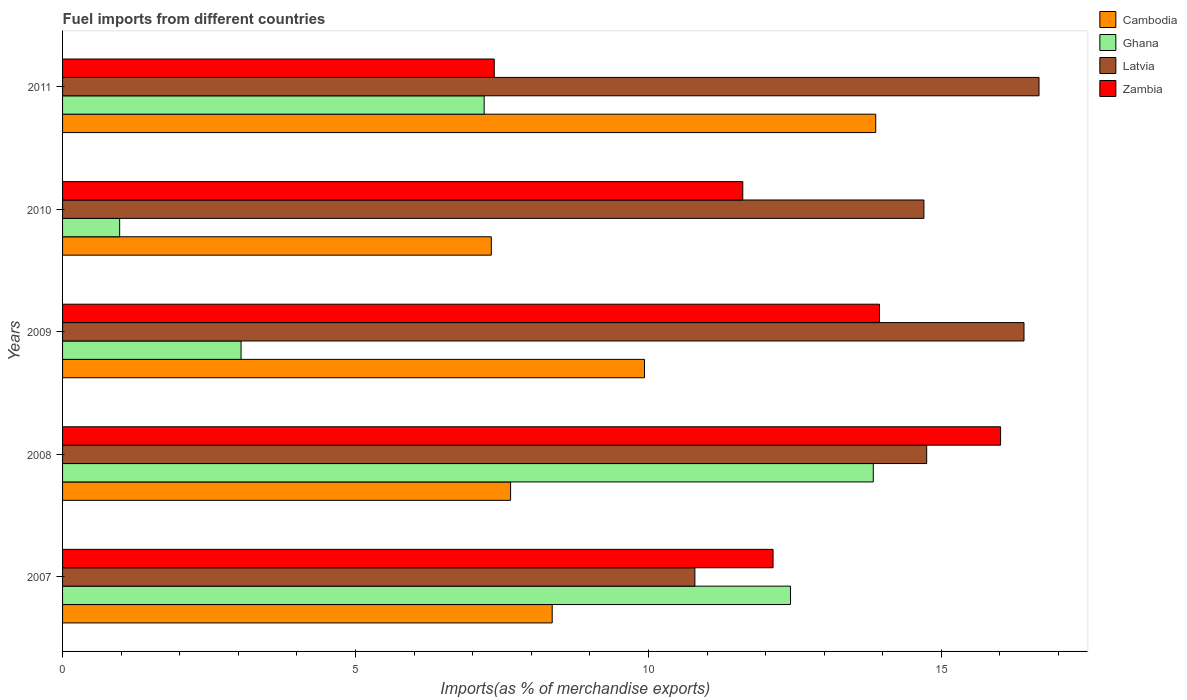How many groups of bars are there?
Keep it short and to the point. 5. Are the number of bars per tick equal to the number of legend labels?
Make the answer very short. Yes. Are the number of bars on each tick of the Y-axis equal?
Your answer should be very brief. Yes. How many bars are there on the 2nd tick from the top?
Provide a succinct answer. 4. What is the label of the 3rd group of bars from the top?
Provide a succinct answer. 2009. In how many cases, is the number of bars for a given year not equal to the number of legend labels?
Give a very brief answer. 0. What is the percentage of imports to different countries in Cambodia in 2007?
Your answer should be very brief. 8.36. Across all years, what is the maximum percentage of imports to different countries in Ghana?
Keep it short and to the point. 13.84. Across all years, what is the minimum percentage of imports to different countries in Cambodia?
Provide a short and direct response. 7.32. In which year was the percentage of imports to different countries in Zambia maximum?
Offer a terse response. 2008. In which year was the percentage of imports to different countries in Cambodia minimum?
Keep it short and to the point. 2010. What is the total percentage of imports to different countries in Zambia in the graph?
Ensure brevity in your answer.  61.06. What is the difference between the percentage of imports to different countries in Zambia in 2009 and that in 2010?
Offer a very short reply. 2.33. What is the difference between the percentage of imports to different countries in Zambia in 2009 and the percentage of imports to different countries in Ghana in 2007?
Ensure brevity in your answer.  1.52. What is the average percentage of imports to different countries in Zambia per year?
Your response must be concise. 12.21. In the year 2011, what is the difference between the percentage of imports to different countries in Ghana and percentage of imports to different countries in Cambodia?
Keep it short and to the point. -6.68. In how many years, is the percentage of imports to different countries in Ghana greater than 11 %?
Give a very brief answer. 2. What is the ratio of the percentage of imports to different countries in Latvia in 2008 to that in 2011?
Keep it short and to the point. 0.88. What is the difference between the highest and the second highest percentage of imports to different countries in Cambodia?
Offer a very short reply. 3.95. What is the difference between the highest and the lowest percentage of imports to different countries in Cambodia?
Provide a short and direct response. 6.56. Is the sum of the percentage of imports to different countries in Latvia in 2008 and 2009 greater than the maximum percentage of imports to different countries in Cambodia across all years?
Offer a terse response. Yes. Is it the case that in every year, the sum of the percentage of imports to different countries in Ghana and percentage of imports to different countries in Cambodia is greater than the sum of percentage of imports to different countries in Latvia and percentage of imports to different countries in Zambia?
Offer a terse response. No. What does the 1st bar from the top in 2011 represents?
Offer a very short reply. Zambia. What does the 4th bar from the bottom in 2010 represents?
Provide a succinct answer. Zambia. Are all the bars in the graph horizontal?
Make the answer very short. Yes. What is the difference between two consecutive major ticks on the X-axis?
Your answer should be very brief. 5. Does the graph contain any zero values?
Your answer should be compact. No. Does the graph contain grids?
Make the answer very short. No. How many legend labels are there?
Provide a succinct answer. 4. What is the title of the graph?
Ensure brevity in your answer.  Fuel imports from different countries. Does "Mexico" appear as one of the legend labels in the graph?
Provide a short and direct response. No. What is the label or title of the X-axis?
Provide a succinct answer. Imports(as % of merchandise exports). What is the label or title of the Y-axis?
Provide a succinct answer. Years. What is the Imports(as % of merchandise exports) of Cambodia in 2007?
Give a very brief answer. 8.36. What is the Imports(as % of merchandise exports) in Ghana in 2007?
Provide a short and direct response. 12.43. What is the Imports(as % of merchandise exports) of Latvia in 2007?
Offer a very short reply. 10.79. What is the Imports(as % of merchandise exports) in Zambia in 2007?
Make the answer very short. 12.13. What is the Imports(as % of merchandise exports) in Cambodia in 2008?
Ensure brevity in your answer.  7.65. What is the Imports(as % of merchandise exports) of Ghana in 2008?
Offer a terse response. 13.84. What is the Imports(as % of merchandise exports) in Latvia in 2008?
Your response must be concise. 14.75. What is the Imports(as % of merchandise exports) of Zambia in 2008?
Make the answer very short. 16.01. What is the Imports(as % of merchandise exports) in Cambodia in 2009?
Provide a short and direct response. 9.93. What is the Imports(as % of merchandise exports) of Ghana in 2009?
Keep it short and to the point. 3.05. What is the Imports(as % of merchandise exports) in Latvia in 2009?
Ensure brevity in your answer.  16.41. What is the Imports(as % of merchandise exports) in Zambia in 2009?
Your answer should be compact. 13.94. What is the Imports(as % of merchandise exports) in Cambodia in 2010?
Ensure brevity in your answer.  7.32. What is the Imports(as % of merchandise exports) in Ghana in 2010?
Ensure brevity in your answer.  0.97. What is the Imports(as % of merchandise exports) of Latvia in 2010?
Offer a very short reply. 14.7. What is the Imports(as % of merchandise exports) of Zambia in 2010?
Your response must be concise. 11.61. What is the Imports(as % of merchandise exports) in Cambodia in 2011?
Make the answer very short. 13.88. What is the Imports(as % of merchandise exports) of Ghana in 2011?
Provide a short and direct response. 7.2. What is the Imports(as % of merchandise exports) in Latvia in 2011?
Make the answer very short. 16.67. What is the Imports(as % of merchandise exports) in Zambia in 2011?
Keep it short and to the point. 7.37. Across all years, what is the maximum Imports(as % of merchandise exports) in Cambodia?
Your response must be concise. 13.88. Across all years, what is the maximum Imports(as % of merchandise exports) of Ghana?
Your response must be concise. 13.84. Across all years, what is the maximum Imports(as % of merchandise exports) of Latvia?
Your answer should be very brief. 16.67. Across all years, what is the maximum Imports(as % of merchandise exports) of Zambia?
Offer a terse response. 16.01. Across all years, what is the minimum Imports(as % of merchandise exports) of Cambodia?
Your response must be concise. 7.32. Across all years, what is the minimum Imports(as % of merchandise exports) in Ghana?
Your answer should be very brief. 0.97. Across all years, what is the minimum Imports(as % of merchandise exports) of Latvia?
Give a very brief answer. 10.79. Across all years, what is the minimum Imports(as % of merchandise exports) of Zambia?
Your answer should be compact. 7.37. What is the total Imports(as % of merchandise exports) of Cambodia in the graph?
Make the answer very short. 47.13. What is the total Imports(as % of merchandise exports) of Ghana in the graph?
Ensure brevity in your answer.  37.48. What is the total Imports(as % of merchandise exports) of Latvia in the graph?
Give a very brief answer. 73.32. What is the total Imports(as % of merchandise exports) of Zambia in the graph?
Give a very brief answer. 61.06. What is the difference between the Imports(as % of merchandise exports) of Cambodia in 2007 and that in 2008?
Keep it short and to the point. 0.71. What is the difference between the Imports(as % of merchandise exports) of Ghana in 2007 and that in 2008?
Provide a short and direct response. -1.41. What is the difference between the Imports(as % of merchandise exports) in Latvia in 2007 and that in 2008?
Your answer should be compact. -3.96. What is the difference between the Imports(as % of merchandise exports) of Zambia in 2007 and that in 2008?
Your answer should be very brief. -3.88. What is the difference between the Imports(as % of merchandise exports) of Cambodia in 2007 and that in 2009?
Ensure brevity in your answer.  -1.57. What is the difference between the Imports(as % of merchandise exports) in Ghana in 2007 and that in 2009?
Your answer should be very brief. 9.38. What is the difference between the Imports(as % of merchandise exports) of Latvia in 2007 and that in 2009?
Your response must be concise. -5.62. What is the difference between the Imports(as % of merchandise exports) of Zambia in 2007 and that in 2009?
Make the answer very short. -1.82. What is the difference between the Imports(as % of merchandise exports) of Cambodia in 2007 and that in 2010?
Offer a very short reply. 1.04. What is the difference between the Imports(as % of merchandise exports) of Ghana in 2007 and that in 2010?
Make the answer very short. 11.45. What is the difference between the Imports(as % of merchandise exports) of Latvia in 2007 and that in 2010?
Offer a very short reply. -3.91. What is the difference between the Imports(as % of merchandise exports) of Zambia in 2007 and that in 2010?
Your answer should be compact. 0.52. What is the difference between the Imports(as % of merchandise exports) of Cambodia in 2007 and that in 2011?
Provide a succinct answer. -5.52. What is the difference between the Imports(as % of merchandise exports) in Ghana in 2007 and that in 2011?
Provide a short and direct response. 5.23. What is the difference between the Imports(as % of merchandise exports) of Latvia in 2007 and that in 2011?
Provide a short and direct response. -5.87. What is the difference between the Imports(as % of merchandise exports) in Zambia in 2007 and that in 2011?
Keep it short and to the point. 4.76. What is the difference between the Imports(as % of merchandise exports) of Cambodia in 2008 and that in 2009?
Ensure brevity in your answer.  -2.29. What is the difference between the Imports(as % of merchandise exports) in Ghana in 2008 and that in 2009?
Ensure brevity in your answer.  10.79. What is the difference between the Imports(as % of merchandise exports) in Latvia in 2008 and that in 2009?
Give a very brief answer. -1.66. What is the difference between the Imports(as % of merchandise exports) in Zambia in 2008 and that in 2009?
Make the answer very short. 2.07. What is the difference between the Imports(as % of merchandise exports) in Cambodia in 2008 and that in 2010?
Give a very brief answer. 0.33. What is the difference between the Imports(as % of merchandise exports) of Ghana in 2008 and that in 2010?
Keep it short and to the point. 12.86. What is the difference between the Imports(as % of merchandise exports) of Latvia in 2008 and that in 2010?
Provide a short and direct response. 0.05. What is the difference between the Imports(as % of merchandise exports) of Zambia in 2008 and that in 2010?
Make the answer very short. 4.4. What is the difference between the Imports(as % of merchandise exports) in Cambodia in 2008 and that in 2011?
Keep it short and to the point. -6.23. What is the difference between the Imports(as % of merchandise exports) of Ghana in 2008 and that in 2011?
Provide a short and direct response. 6.64. What is the difference between the Imports(as % of merchandise exports) of Latvia in 2008 and that in 2011?
Provide a succinct answer. -1.92. What is the difference between the Imports(as % of merchandise exports) in Zambia in 2008 and that in 2011?
Give a very brief answer. 8.64. What is the difference between the Imports(as % of merchandise exports) of Cambodia in 2009 and that in 2010?
Your answer should be compact. 2.61. What is the difference between the Imports(as % of merchandise exports) in Ghana in 2009 and that in 2010?
Offer a very short reply. 2.07. What is the difference between the Imports(as % of merchandise exports) of Latvia in 2009 and that in 2010?
Provide a short and direct response. 1.71. What is the difference between the Imports(as % of merchandise exports) of Zambia in 2009 and that in 2010?
Your answer should be compact. 2.33. What is the difference between the Imports(as % of merchandise exports) in Cambodia in 2009 and that in 2011?
Offer a terse response. -3.95. What is the difference between the Imports(as % of merchandise exports) in Ghana in 2009 and that in 2011?
Keep it short and to the point. -4.15. What is the difference between the Imports(as % of merchandise exports) of Latvia in 2009 and that in 2011?
Your response must be concise. -0.26. What is the difference between the Imports(as % of merchandise exports) of Zambia in 2009 and that in 2011?
Keep it short and to the point. 6.58. What is the difference between the Imports(as % of merchandise exports) in Cambodia in 2010 and that in 2011?
Give a very brief answer. -6.56. What is the difference between the Imports(as % of merchandise exports) in Ghana in 2010 and that in 2011?
Your answer should be very brief. -6.22. What is the difference between the Imports(as % of merchandise exports) of Latvia in 2010 and that in 2011?
Provide a succinct answer. -1.96. What is the difference between the Imports(as % of merchandise exports) of Zambia in 2010 and that in 2011?
Ensure brevity in your answer.  4.24. What is the difference between the Imports(as % of merchandise exports) of Cambodia in 2007 and the Imports(as % of merchandise exports) of Ghana in 2008?
Keep it short and to the point. -5.48. What is the difference between the Imports(as % of merchandise exports) of Cambodia in 2007 and the Imports(as % of merchandise exports) of Latvia in 2008?
Your response must be concise. -6.39. What is the difference between the Imports(as % of merchandise exports) in Cambodia in 2007 and the Imports(as % of merchandise exports) in Zambia in 2008?
Your answer should be compact. -7.65. What is the difference between the Imports(as % of merchandise exports) in Ghana in 2007 and the Imports(as % of merchandise exports) in Latvia in 2008?
Your answer should be compact. -2.32. What is the difference between the Imports(as % of merchandise exports) in Ghana in 2007 and the Imports(as % of merchandise exports) in Zambia in 2008?
Your answer should be very brief. -3.59. What is the difference between the Imports(as % of merchandise exports) in Latvia in 2007 and the Imports(as % of merchandise exports) in Zambia in 2008?
Give a very brief answer. -5.22. What is the difference between the Imports(as % of merchandise exports) of Cambodia in 2007 and the Imports(as % of merchandise exports) of Ghana in 2009?
Make the answer very short. 5.31. What is the difference between the Imports(as % of merchandise exports) in Cambodia in 2007 and the Imports(as % of merchandise exports) in Latvia in 2009?
Your response must be concise. -8.05. What is the difference between the Imports(as % of merchandise exports) in Cambodia in 2007 and the Imports(as % of merchandise exports) in Zambia in 2009?
Offer a terse response. -5.59. What is the difference between the Imports(as % of merchandise exports) of Ghana in 2007 and the Imports(as % of merchandise exports) of Latvia in 2009?
Offer a very short reply. -3.99. What is the difference between the Imports(as % of merchandise exports) in Ghana in 2007 and the Imports(as % of merchandise exports) in Zambia in 2009?
Offer a very short reply. -1.52. What is the difference between the Imports(as % of merchandise exports) of Latvia in 2007 and the Imports(as % of merchandise exports) of Zambia in 2009?
Offer a very short reply. -3.15. What is the difference between the Imports(as % of merchandise exports) of Cambodia in 2007 and the Imports(as % of merchandise exports) of Ghana in 2010?
Make the answer very short. 7.38. What is the difference between the Imports(as % of merchandise exports) in Cambodia in 2007 and the Imports(as % of merchandise exports) in Latvia in 2010?
Keep it short and to the point. -6.34. What is the difference between the Imports(as % of merchandise exports) of Cambodia in 2007 and the Imports(as % of merchandise exports) of Zambia in 2010?
Keep it short and to the point. -3.25. What is the difference between the Imports(as % of merchandise exports) of Ghana in 2007 and the Imports(as % of merchandise exports) of Latvia in 2010?
Provide a short and direct response. -2.28. What is the difference between the Imports(as % of merchandise exports) of Ghana in 2007 and the Imports(as % of merchandise exports) of Zambia in 2010?
Ensure brevity in your answer.  0.81. What is the difference between the Imports(as % of merchandise exports) of Latvia in 2007 and the Imports(as % of merchandise exports) of Zambia in 2010?
Make the answer very short. -0.82. What is the difference between the Imports(as % of merchandise exports) of Cambodia in 2007 and the Imports(as % of merchandise exports) of Ghana in 2011?
Your answer should be very brief. 1.16. What is the difference between the Imports(as % of merchandise exports) in Cambodia in 2007 and the Imports(as % of merchandise exports) in Latvia in 2011?
Offer a very short reply. -8.31. What is the difference between the Imports(as % of merchandise exports) in Ghana in 2007 and the Imports(as % of merchandise exports) in Latvia in 2011?
Provide a succinct answer. -4.24. What is the difference between the Imports(as % of merchandise exports) of Ghana in 2007 and the Imports(as % of merchandise exports) of Zambia in 2011?
Make the answer very short. 5.06. What is the difference between the Imports(as % of merchandise exports) in Latvia in 2007 and the Imports(as % of merchandise exports) in Zambia in 2011?
Keep it short and to the point. 3.42. What is the difference between the Imports(as % of merchandise exports) of Cambodia in 2008 and the Imports(as % of merchandise exports) of Ghana in 2009?
Provide a succinct answer. 4.6. What is the difference between the Imports(as % of merchandise exports) in Cambodia in 2008 and the Imports(as % of merchandise exports) in Latvia in 2009?
Ensure brevity in your answer.  -8.76. What is the difference between the Imports(as % of merchandise exports) in Cambodia in 2008 and the Imports(as % of merchandise exports) in Zambia in 2009?
Provide a short and direct response. -6.3. What is the difference between the Imports(as % of merchandise exports) of Ghana in 2008 and the Imports(as % of merchandise exports) of Latvia in 2009?
Offer a very short reply. -2.57. What is the difference between the Imports(as % of merchandise exports) of Ghana in 2008 and the Imports(as % of merchandise exports) of Zambia in 2009?
Ensure brevity in your answer.  -0.11. What is the difference between the Imports(as % of merchandise exports) in Latvia in 2008 and the Imports(as % of merchandise exports) in Zambia in 2009?
Your response must be concise. 0.81. What is the difference between the Imports(as % of merchandise exports) of Cambodia in 2008 and the Imports(as % of merchandise exports) of Ghana in 2010?
Your answer should be very brief. 6.67. What is the difference between the Imports(as % of merchandise exports) in Cambodia in 2008 and the Imports(as % of merchandise exports) in Latvia in 2010?
Your answer should be compact. -7.05. What is the difference between the Imports(as % of merchandise exports) of Cambodia in 2008 and the Imports(as % of merchandise exports) of Zambia in 2010?
Keep it short and to the point. -3.96. What is the difference between the Imports(as % of merchandise exports) of Ghana in 2008 and the Imports(as % of merchandise exports) of Latvia in 2010?
Provide a succinct answer. -0.86. What is the difference between the Imports(as % of merchandise exports) of Ghana in 2008 and the Imports(as % of merchandise exports) of Zambia in 2010?
Ensure brevity in your answer.  2.23. What is the difference between the Imports(as % of merchandise exports) in Latvia in 2008 and the Imports(as % of merchandise exports) in Zambia in 2010?
Offer a terse response. 3.14. What is the difference between the Imports(as % of merchandise exports) in Cambodia in 2008 and the Imports(as % of merchandise exports) in Ghana in 2011?
Your response must be concise. 0.45. What is the difference between the Imports(as % of merchandise exports) in Cambodia in 2008 and the Imports(as % of merchandise exports) in Latvia in 2011?
Provide a succinct answer. -9.02. What is the difference between the Imports(as % of merchandise exports) of Cambodia in 2008 and the Imports(as % of merchandise exports) of Zambia in 2011?
Keep it short and to the point. 0.28. What is the difference between the Imports(as % of merchandise exports) in Ghana in 2008 and the Imports(as % of merchandise exports) in Latvia in 2011?
Ensure brevity in your answer.  -2.83. What is the difference between the Imports(as % of merchandise exports) in Ghana in 2008 and the Imports(as % of merchandise exports) in Zambia in 2011?
Your answer should be compact. 6.47. What is the difference between the Imports(as % of merchandise exports) of Latvia in 2008 and the Imports(as % of merchandise exports) of Zambia in 2011?
Keep it short and to the point. 7.38. What is the difference between the Imports(as % of merchandise exports) in Cambodia in 2009 and the Imports(as % of merchandise exports) in Ghana in 2010?
Provide a short and direct response. 8.96. What is the difference between the Imports(as % of merchandise exports) of Cambodia in 2009 and the Imports(as % of merchandise exports) of Latvia in 2010?
Your answer should be compact. -4.77. What is the difference between the Imports(as % of merchandise exports) in Cambodia in 2009 and the Imports(as % of merchandise exports) in Zambia in 2010?
Your answer should be compact. -1.68. What is the difference between the Imports(as % of merchandise exports) of Ghana in 2009 and the Imports(as % of merchandise exports) of Latvia in 2010?
Provide a short and direct response. -11.66. What is the difference between the Imports(as % of merchandise exports) in Ghana in 2009 and the Imports(as % of merchandise exports) in Zambia in 2010?
Keep it short and to the point. -8.56. What is the difference between the Imports(as % of merchandise exports) in Cambodia in 2009 and the Imports(as % of merchandise exports) in Ghana in 2011?
Your answer should be very brief. 2.74. What is the difference between the Imports(as % of merchandise exports) of Cambodia in 2009 and the Imports(as % of merchandise exports) of Latvia in 2011?
Provide a succinct answer. -6.73. What is the difference between the Imports(as % of merchandise exports) of Cambodia in 2009 and the Imports(as % of merchandise exports) of Zambia in 2011?
Make the answer very short. 2.56. What is the difference between the Imports(as % of merchandise exports) in Ghana in 2009 and the Imports(as % of merchandise exports) in Latvia in 2011?
Your answer should be very brief. -13.62. What is the difference between the Imports(as % of merchandise exports) in Ghana in 2009 and the Imports(as % of merchandise exports) in Zambia in 2011?
Your response must be concise. -4.32. What is the difference between the Imports(as % of merchandise exports) of Latvia in 2009 and the Imports(as % of merchandise exports) of Zambia in 2011?
Give a very brief answer. 9.04. What is the difference between the Imports(as % of merchandise exports) in Cambodia in 2010 and the Imports(as % of merchandise exports) in Ghana in 2011?
Your answer should be compact. 0.12. What is the difference between the Imports(as % of merchandise exports) in Cambodia in 2010 and the Imports(as % of merchandise exports) in Latvia in 2011?
Offer a very short reply. -9.35. What is the difference between the Imports(as % of merchandise exports) in Cambodia in 2010 and the Imports(as % of merchandise exports) in Zambia in 2011?
Keep it short and to the point. -0.05. What is the difference between the Imports(as % of merchandise exports) in Ghana in 2010 and the Imports(as % of merchandise exports) in Latvia in 2011?
Provide a short and direct response. -15.69. What is the difference between the Imports(as % of merchandise exports) in Ghana in 2010 and the Imports(as % of merchandise exports) in Zambia in 2011?
Give a very brief answer. -6.39. What is the difference between the Imports(as % of merchandise exports) of Latvia in 2010 and the Imports(as % of merchandise exports) of Zambia in 2011?
Your response must be concise. 7.33. What is the average Imports(as % of merchandise exports) of Cambodia per year?
Give a very brief answer. 9.43. What is the average Imports(as % of merchandise exports) in Ghana per year?
Offer a terse response. 7.5. What is the average Imports(as % of merchandise exports) of Latvia per year?
Give a very brief answer. 14.66. What is the average Imports(as % of merchandise exports) of Zambia per year?
Ensure brevity in your answer.  12.21. In the year 2007, what is the difference between the Imports(as % of merchandise exports) of Cambodia and Imports(as % of merchandise exports) of Ghana?
Offer a very short reply. -4.07. In the year 2007, what is the difference between the Imports(as % of merchandise exports) in Cambodia and Imports(as % of merchandise exports) in Latvia?
Ensure brevity in your answer.  -2.44. In the year 2007, what is the difference between the Imports(as % of merchandise exports) of Cambodia and Imports(as % of merchandise exports) of Zambia?
Your response must be concise. -3.77. In the year 2007, what is the difference between the Imports(as % of merchandise exports) in Ghana and Imports(as % of merchandise exports) in Latvia?
Provide a succinct answer. 1.63. In the year 2007, what is the difference between the Imports(as % of merchandise exports) of Ghana and Imports(as % of merchandise exports) of Zambia?
Offer a terse response. 0.3. In the year 2007, what is the difference between the Imports(as % of merchandise exports) of Latvia and Imports(as % of merchandise exports) of Zambia?
Make the answer very short. -1.33. In the year 2008, what is the difference between the Imports(as % of merchandise exports) of Cambodia and Imports(as % of merchandise exports) of Ghana?
Give a very brief answer. -6.19. In the year 2008, what is the difference between the Imports(as % of merchandise exports) of Cambodia and Imports(as % of merchandise exports) of Latvia?
Make the answer very short. -7.1. In the year 2008, what is the difference between the Imports(as % of merchandise exports) in Cambodia and Imports(as % of merchandise exports) in Zambia?
Give a very brief answer. -8.36. In the year 2008, what is the difference between the Imports(as % of merchandise exports) of Ghana and Imports(as % of merchandise exports) of Latvia?
Make the answer very short. -0.91. In the year 2008, what is the difference between the Imports(as % of merchandise exports) of Ghana and Imports(as % of merchandise exports) of Zambia?
Your answer should be compact. -2.17. In the year 2008, what is the difference between the Imports(as % of merchandise exports) of Latvia and Imports(as % of merchandise exports) of Zambia?
Your answer should be very brief. -1.26. In the year 2009, what is the difference between the Imports(as % of merchandise exports) of Cambodia and Imports(as % of merchandise exports) of Ghana?
Give a very brief answer. 6.89. In the year 2009, what is the difference between the Imports(as % of merchandise exports) of Cambodia and Imports(as % of merchandise exports) of Latvia?
Provide a short and direct response. -6.48. In the year 2009, what is the difference between the Imports(as % of merchandise exports) of Cambodia and Imports(as % of merchandise exports) of Zambia?
Your response must be concise. -4.01. In the year 2009, what is the difference between the Imports(as % of merchandise exports) of Ghana and Imports(as % of merchandise exports) of Latvia?
Your answer should be very brief. -13.36. In the year 2009, what is the difference between the Imports(as % of merchandise exports) in Ghana and Imports(as % of merchandise exports) in Zambia?
Give a very brief answer. -10.9. In the year 2009, what is the difference between the Imports(as % of merchandise exports) in Latvia and Imports(as % of merchandise exports) in Zambia?
Keep it short and to the point. 2.47. In the year 2010, what is the difference between the Imports(as % of merchandise exports) in Cambodia and Imports(as % of merchandise exports) in Ghana?
Keep it short and to the point. 6.34. In the year 2010, what is the difference between the Imports(as % of merchandise exports) in Cambodia and Imports(as % of merchandise exports) in Latvia?
Your response must be concise. -7.38. In the year 2010, what is the difference between the Imports(as % of merchandise exports) of Cambodia and Imports(as % of merchandise exports) of Zambia?
Your answer should be compact. -4.29. In the year 2010, what is the difference between the Imports(as % of merchandise exports) of Ghana and Imports(as % of merchandise exports) of Latvia?
Your answer should be very brief. -13.73. In the year 2010, what is the difference between the Imports(as % of merchandise exports) of Ghana and Imports(as % of merchandise exports) of Zambia?
Your answer should be compact. -10.64. In the year 2010, what is the difference between the Imports(as % of merchandise exports) in Latvia and Imports(as % of merchandise exports) in Zambia?
Your response must be concise. 3.09. In the year 2011, what is the difference between the Imports(as % of merchandise exports) in Cambodia and Imports(as % of merchandise exports) in Ghana?
Ensure brevity in your answer.  6.68. In the year 2011, what is the difference between the Imports(as % of merchandise exports) in Cambodia and Imports(as % of merchandise exports) in Latvia?
Give a very brief answer. -2.79. In the year 2011, what is the difference between the Imports(as % of merchandise exports) of Cambodia and Imports(as % of merchandise exports) of Zambia?
Your response must be concise. 6.51. In the year 2011, what is the difference between the Imports(as % of merchandise exports) in Ghana and Imports(as % of merchandise exports) in Latvia?
Provide a short and direct response. -9.47. In the year 2011, what is the difference between the Imports(as % of merchandise exports) in Ghana and Imports(as % of merchandise exports) in Zambia?
Your answer should be compact. -0.17. In the year 2011, what is the difference between the Imports(as % of merchandise exports) of Latvia and Imports(as % of merchandise exports) of Zambia?
Offer a terse response. 9.3. What is the ratio of the Imports(as % of merchandise exports) in Cambodia in 2007 to that in 2008?
Your response must be concise. 1.09. What is the ratio of the Imports(as % of merchandise exports) of Ghana in 2007 to that in 2008?
Offer a terse response. 0.9. What is the ratio of the Imports(as % of merchandise exports) of Latvia in 2007 to that in 2008?
Your answer should be compact. 0.73. What is the ratio of the Imports(as % of merchandise exports) in Zambia in 2007 to that in 2008?
Give a very brief answer. 0.76. What is the ratio of the Imports(as % of merchandise exports) of Cambodia in 2007 to that in 2009?
Provide a short and direct response. 0.84. What is the ratio of the Imports(as % of merchandise exports) in Ghana in 2007 to that in 2009?
Your answer should be very brief. 4.08. What is the ratio of the Imports(as % of merchandise exports) in Latvia in 2007 to that in 2009?
Make the answer very short. 0.66. What is the ratio of the Imports(as % of merchandise exports) in Zambia in 2007 to that in 2009?
Offer a terse response. 0.87. What is the ratio of the Imports(as % of merchandise exports) in Cambodia in 2007 to that in 2010?
Keep it short and to the point. 1.14. What is the ratio of the Imports(as % of merchandise exports) of Ghana in 2007 to that in 2010?
Your answer should be very brief. 12.75. What is the ratio of the Imports(as % of merchandise exports) of Latvia in 2007 to that in 2010?
Give a very brief answer. 0.73. What is the ratio of the Imports(as % of merchandise exports) in Zambia in 2007 to that in 2010?
Your answer should be compact. 1.04. What is the ratio of the Imports(as % of merchandise exports) in Cambodia in 2007 to that in 2011?
Your response must be concise. 0.6. What is the ratio of the Imports(as % of merchandise exports) of Ghana in 2007 to that in 2011?
Offer a terse response. 1.73. What is the ratio of the Imports(as % of merchandise exports) in Latvia in 2007 to that in 2011?
Provide a succinct answer. 0.65. What is the ratio of the Imports(as % of merchandise exports) of Zambia in 2007 to that in 2011?
Offer a terse response. 1.65. What is the ratio of the Imports(as % of merchandise exports) of Cambodia in 2008 to that in 2009?
Offer a terse response. 0.77. What is the ratio of the Imports(as % of merchandise exports) of Ghana in 2008 to that in 2009?
Your response must be concise. 4.54. What is the ratio of the Imports(as % of merchandise exports) of Latvia in 2008 to that in 2009?
Ensure brevity in your answer.  0.9. What is the ratio of the Imports(as % of merchandise exports) of Zambia in 2008 to that in 2009?
Offer a terse response. 1.15. What is the ratio of the Imports(as % of merchandise exports) in Cambodia in 2008 to that in 2010?
Provide a succinct answer. 1.04. What is the ratio of the Imports(as % of merchandise exports) of Ghana in 2008 to that in 2010?
Provide a succinct answer. 14.2. What is the ratio of the Imports(as % of merchandise exports) in Zambia in 2008 to that in 2010?
Give a very brief answer. 1.38. What is the ratio of the Imports(as % of merchandise exports) in Cambodia in 2008 to that in 2011?
Make the answer very short. 0.55. What is the ratio of the Imports(as % of merchandise exports) of Ghana in 2008 to that in 2011?
Provide a succinct answer. 1.92. What is the ratio of the Imports(as % of merchandise exports) in Latvia in 2008 to that in 2011?
Provide a succinct answer. 0.89. What is the ratio of the Imports(as % of merchandise exports) of Zambia in 2008 to that in 2011?
Make the answer very short. 2.17. What is the ratio of the Imports(as % of merchandise exports) of Cambodia in 2009 to that in 2010?
Your answer should be compact. 1.36. What is the ratio of the Imports(as % of merchandise exports) in Ghana in 2009 to that in 2010?
Make the answer very short. 3.13. What is the ratio of the Imports(as % of merchandise exports) in Latvia in 2009 to that in 2010?
Give a very brief answer. 1.12. What is the ratio of the Imports(as % of merchandise exports) in Zambia in 2009 to that in 2010?
Offer a very short reply. 1.2. What is the ratio of the Imports(as % of merchandise exports) of Cambodia in 2009 to that in 2011?
Your answer should be very brief. 0.72. What is the ratio of the Imports(as % of merchandise exports) of Ghana in 2009 to that in 2011?
Your answer should be very brief. 0.42. What is the ratio of the Imports(as % of merchandise exports) in Latvia in 2009 to that in 2011?
Provide a short and direct response. 0.98. What is the ratio of the Imports(as % of merchandise exports) of Zambia in 2009 to that in 2011?
Your response must be concise. 1.89. What is the ratio of the Imports(as % of merchandise exports) of Cambodia in 2010 to that in 2011?
Offer a very short reply. 0.53. What is the ratio of the Imports(as % of merchandise exports) of Ghana in 2010 to that in 2011?
Provide a short and direct response. 0.14. What is the ratio of the Imports(as % of merchandise exports) in Latvia in 2010 to that in 2011?
Your response must be concise. 0.88. What is the ratio of the Imports(as % of merchandise exports) in Zambia in 2010 to that in 2011?
Give a very brief answer. 1.58. What is the difference between the highest and the second highest Imports(as % of merchandise exports) in Cambodia?
Give a very brief answer. 3.95. What is the difference between the highest and the second highest Imports(as % of merchandise exports) in Ghana?
Provide a short and direct response. 1.41. What is the difference between the highest and the second highest Imports(as % of merchandise exports) in Latvia?
Make the answer very short. 0.26. What is the difference between the highest and the second highest Imports(as % of merchandise exports) of Zambia?
Make the answer very short. 2.07. What is the difference between the highest and the lowest Imports(as % of merchandise exports) in Cambodia?
Your answer should be compact. 6.56. What is the difference between the highest and the lowest Imports(as % of merchandise exports) of Ghana?
Give a very brief answer. 12.86. What is the difference between the highest and the lowest Imports(as % of merchandise exports) in Latvia?
Ensure brevity in your answer.  5.87. What is the difference between the highest and the lowest Imports(as % of merchandise exports) of Zambia?
Give a very brief answer. 8.64. 